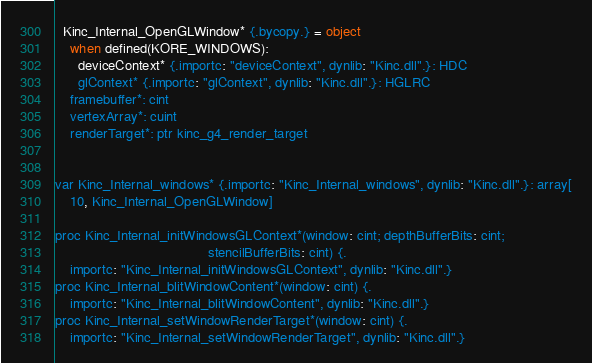Convert code to text. <code><loc_0><loc_0><loc_500><loc_500><_Nim_>  Kinc_Internal_OpenGLWindow* {.bycopy.} = object
    when defined(KORE_WINDOWS):
      deviceContext* {.importc: "deviceContext", dynlib: "Kinc.dll".}: HDC
      glContext* {.importc: "glContext", dynlib: "Kinc.dll".}: HGLRC
    framebuffer*: cint
    vertexArray*: cuint
    renderTarget*: ptr kinc_g4_render_target


var Kinc_Internal_windows* {.importc: "Kinc_Internal_windows", dynlib: "Kinc.dll".}: array[
    10, Kinc_Internal_OpenGLWindow]

proc Kinc_Internal_initWindowsGLContext*(window: cint; depthBufferBits: cint;
                                        stencilBufferBits: cint) {.
    importc: "Kinc_Internal_initWindowsGLContext", dynlib: "Kinc.dll".}
proc Kinc_Internal_blitWindowContent*(window: cint) {.
    importc: "Kinc_Internal_blitWindowContent", dynlib: "Kinc.dll".}
proc Kinc_Internal_setWindowRenderTarget*(window: cint) {.
    importc: "Kinc_Internal_setWindowRenderTarget", dynlib: "Kinc.dll".}</code> 